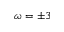Convert formula to latex. <formula><loc_0><loc_0><loc_500><loc_500>\omega = \pm 3</formula> 